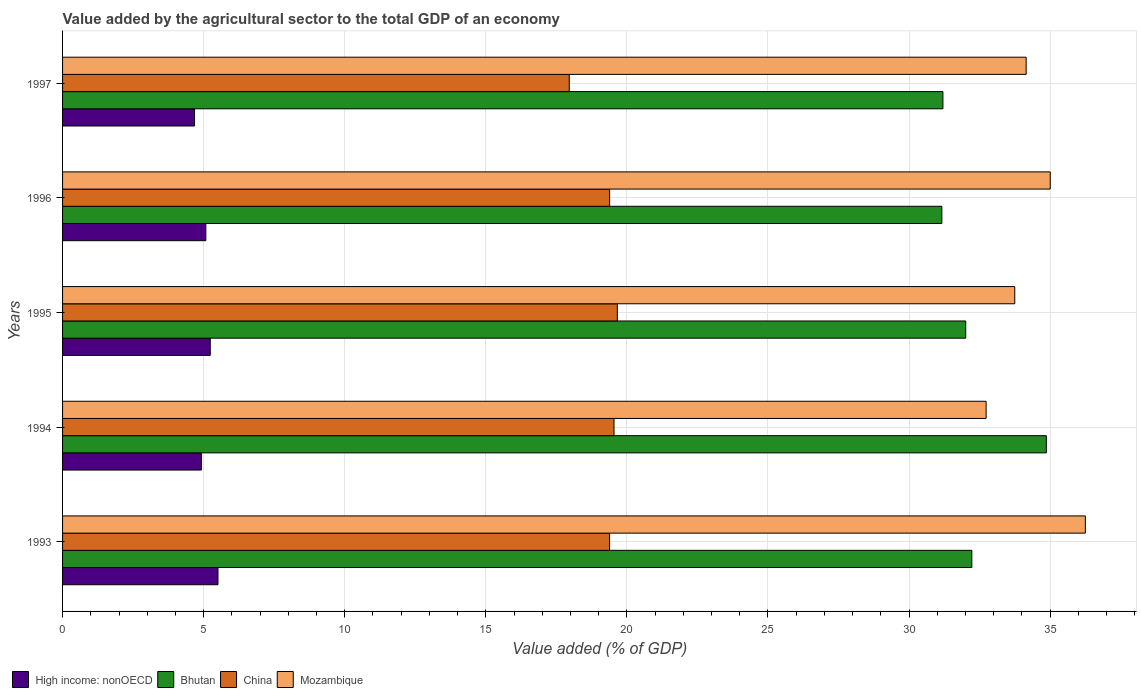How many groups of bars are there?
Provide a short and direct response. 5. Are the number of bars per tick equal to the number of legend labels?
Give a very brief answer. Yes. How many bars are there on the 3rd tick from the bottom?
Ensure brevity in your answer.  4. What is the value added by the agricultural sector to the total GDP in High income: nonOECD in 1996?
Provide a short and direct response. 5.08. Across all years, what is the maximum value added by the agricultural sector to the total GDP in High income: nonOECD?
Your answer should be very brief. 5.51. Across all years, what is the minimum value added by the agricultural sector to the total GDP in China?
Your answer should be very brief. 17.96. In which year was the value added by the agricultural sector to the total GDP in High income: nonOECD maximum?
Your answer should be very brief. 1993. In which year was the value added by the agricultural sector to the total GDP in Mozambique minimum?
Keep it short and to the point. 1994. What is the total value added by the agricultural sector to the total GDP in Mozambique in the graph?
Your answer should be compact. 171.89. What is the difference between the value added by the agricultural sector to the total GDP in China in 1996 and that in 1997?
Your answer should be very brief. 1.43. What is the difference between the value added by the agricultural sector to the total GDP in Mozambique in 1993 and the value added by the agricultural sector to the total GDP in Bhutan in 1996?
Give a very brief answer. 5.09. What is the average value added by the agricultural sector to the total GDP in China per year?
Your answer should be very brief. 19.19. In the year 1993, what is the difference between the value added by the agricultural sector to the total GDP in High income: nonOECD and value added by the agricultural sector to the total GDP in Bhutan?
Provide a short and direct response. -26.72. What is the ratio of the value added by the agricultural sector to the total GDP in High income: nonOECD in 1994 to that in 1997?
Your answer should be compact. 1.05. Is the value added by the agricultural sector to the total GDP in China in 1995 less than that in 1997?
Make the answer very short. No. What is the difference between the highest and the second highest value added by the agricultural sector to the total GDP in Mozambique?
Provide a short and direct response. 1.24. What is the difference between the highest and the lowest value added by the agricultural sector to the total GDP in Bhutan?
Your response must be concise. 3.7. In how many years, is the value added by the agricultural sector to the total GDP in High income: nonOECD greater than the average value added by the agricultural sector to the total GDP in High income: nonOECD taken over all years?
Keep it short and to the point. 2. Is the sum of the value added by the agricultural sector to the total GDP in High income: nonOECD in 1996 and 1997 greater than the maximum value added by the agricultural sector to the total GDP in Mozambique across all years?
Give a very brief answer. No. What does the 3rd bar from the top in 1993 represents?
Your answer should be very brief. Bhutan. What does the 3rd bar from the bottom in 1996 represents?
Keep it short and to the point. China. How many bars are there?
Give a very brief answer. 20. How many years are there in the graph?
Your response must be concise. 5. How many legend labels are there?
Provide a succinct answer. 4. What is the title of the graph?
Keep it short and to the point. Value added by the agricultural sector to the total GDP of an economy. Does "Iceland" appear as one of the legend labels in the graph?
Keep it short and to the point. No. What is the label or title of the X-axis?
Ensure brevity in your answer.  Value added (% of GDP). What is the Value added (% of GDP) in High income: nonOECD in 1993?
Provide a succinct answer. 5.51. What is the Value added (% of GDP) in Bhutan in 1993?
Offer a very short reply. 32.23. What is the Value added (% of GDP) in China in 1993?
Offer a very short reply. 19.39. What is the Value added (% of GDP) in Mozambique in 1993?
Provide a short and direct response. 36.25. What is the Value added (% of GDP) in High income: nonOECD in 1994?
Keep it short and to the point. 4.92. What is the Value added (% of GDP) of Bhutan in 1994?
Your answer should be compact. 34.87. What is the Value added (% of GDP) of China in 1994?
Your response must be concise. 19.54. What is the Value added (% of GDP) in Mozambique in 1994?
Provide a short and direct response. 32.73. What is the Value added (% of GDP) in High income: nonOECD in 1995?
Make the answer very short. 5.23. What is the Value added (% of GDP) in Bhutan in 1995?
Make the answer very short. 32.01. What is the Value added (% of GDP) of China in 1995?
Ensure brevity in your answer.  19.66. What is the Value added (% of GDP) in Mozambique in 1995?
Ensure brevity in your answer.  33.75. What is the Value added (% of GDP) of High income: nonOECD in 1996?
Offer a very short reply. 5.08. What is the Value added (% of GDP) of Bhutan in 1996?
Your response must be concise. 31.16. What is the Value added (% of GDP) in China in 1996?
Your response must be concise. 19.39. What is the Value added (% of GDP) of Mozambique in 1996?
Offer a terse response. 35.01. What is the Value added (% of GDP) in High income: nonOECD in 1997?
Offer a very short reply. 4.68. What is the Value added (% of GDP) in Bhutan in 1997?
Provide a short and direct response. 31.2. What is the Value added (% of GDP) of China in 1997?
Your response must be concise. 17.96. What is the Value added (% of GDP) of Mozambique in 1997?
Your answer should be compact. 34.15. Across all years, what is the maximum Value added (% of GDP) in High income: nonOECD?
Provide a short and direct response. 5.51. Across all years, what is the maximum Value added (% of GDP) of Bhutan?
Keep it short and to the point. 34.87. Across all years, what is the maximum Value added (% of GDP) of China?
Give a very brief answer. 19.66. Across all years, what is the maximum Value added (% of GDP) of Mozambique?
Provide a short and direct response. 36.25. Across all years, what is the minimum Value added (% of GDP) in High income: nonOECD?
Provide a succinct answer. 4.68. Across all years, what is the minimum Value added (% of GDP) in Bhutan?
Keep it short and to the point. 31.16. Across all years, what is the minimum Value added (% of GDP) in China?
Offer a terse response. 17.96. Across all years, what is the minimum Value added (% of GDP) in Mozambique?
Provide a short and direct response. 32.73. What is the total Value added (% of GDP) of High income: nonOECD in the graph?
Ensure brevity in your answer.  25.42. What is the total Value added (% of GDP) of Bhutan in the graph?
Your answer should be very brief. 161.47. What is the total Value added (% of GDP) in China in the graph?
Keep it short and to the point. 95.94. What is the total Value added (% of GDP) of Mozambique in the graph?
Give a very brief answer. 171.89. What is the difference between the Value added (% of GDP) of High income: nonOECD in 1993 and that in 1994?
Ensure brevity in your answer.  0.59. What is the difference between the Value added (% of GDP) of Bhutan in 1993 and that in 1994?
Give a very brief answer. -2.64. What is the difference between the Value added (% of GDP) in China in 1993 and that in 1994?
Give a very brief answer. -0.16. What is the difference between the Value added (% of GDP) in Mozambique in 1993 and that in 1994?
Make the answer very short. 3.52. What is the difference between the Value added (% of GDP) in High income: nonOECD in 1993 and that in 1995?
Your answer should be compact. 0.27. What is the difference between the Value added (% of GDP) in Bhutan in 1993 and that in 1995?
Ensure brevity in your answer.  0.22. What is the difference between the Value added (% of GDP) of China in 1993 and that in 1995?
Offer a terse response. -0.28. What is the difference between the Value added (% of GDP) in Mozambique in 1993 and that in 1995?
Your response must be concise. 2.5. What is the difference between the Value added (% of GDP) of High income: nonOECD in 1993 and that in 1996?
Your answer should be compact. 0.43. What is the difference between the Value added (% of GDP) in Bhutan in 1993 and that in 1996?
Make the answer very short. 1.06. What is the difference between the Value added (% of GDP) of China in 1993 and that in 1996?
Your response must be concise. -0. What is the difference between the Value added (% of GDP) of Mozambique in 1993 and that in 1996?
Give a very brief answer. 1.24. What is the difference between the Value added (% of GDP) in High income: nonOECD in 1993 and that in 1997?
Offer a terse response. 0.83. What is the difference between the Value added (% of GDP) in Bhutan in 1993 and that in 1997?
Ensure brevity in your answer.  1.02. What is the difference between the Value added (% of GDP) of China in 1993 and that in 1997?
Make the answer very short. 1.43. What is the difference between the Value added (% of GDP) of Mozambique in 1993 and that in 1997?
Make the answer very short. 2.1. What is the difference between the Value added (% of GDP) in High income: nonOECD in 1994 and that in 1995?
Offer a very short reply. -0.32. What is the difference between the Value added (% of GDP) of Bhutan in 1994 and that in 1995?
Your answer should be compact. 2.86. What is the difference between the Value added (% of GDP) in China in 1994 and that in 1995?
Make the answer very short. -0.12. What is the difference between the Value added (% of GDP) of Mozambique in 1994 and that in 1995?
Provide a succinct answer. -1.01. What is the difference between the Value added (% of GDP) of High income: nonOECD in 1994 and that in 1996?
Give a very brief answer. -0.16. What is the difference between the Value added (% of GDP) of Bhutan in 1994 and that in 1996?
Provide a short and direct response. 3.7. What is the difference between the Value added (% of GDP) in China in 1994 and that in 1996?
Offer a very short reply. 0.15. What is the difference between the Value added (% of GDP) in Mozambique in 1994 and that in 1996?
Keep it short and to the point. -2.27. What is the difference between the Value added (% of GDP) in High income: nonOECD in 1994 and that in 1997?
Offer a very short reply. 0.24. What is the difference between the Value added (% of GDP) of Bhutan in 1994 and that in 1997?
Make the answer very short. 3.67. What is the difference between the Value added (% of GDP) of China in 1994 and that in 1997?
Provide a short and direct response. 1.59. What is the difference between the Value added (% of GDP) of Mozambique in 1994 and that in 1997?
Make the answer very short. -1.42. What is the difference between the Value added (% of GDP) of High income: nonOECD in 1995 and that in 1996?
Your answer should be compact. 0.16. What is the difference between the Value added (% of GDP) in Bhutan in 1995 and that in 1996?
Offer a terse response. 0.85. What is the difference between the Value added (% of GDP) in China in 1995 and that in 1996?
Offer a very short reply. 0.27. What is the difference between the Value added (% of GDP) in Mozambique in 1995 and that in 1996?
Ensure brevity in your answer.  -1.26. What is the difference between the Value added (% of GDP) in High income: nonOECD in 1995 and that in 1997?
Give a very brief answer. 0.56. What is the difference between the Value added (% of GDP) of Bhutan in 1995 and that in 1997?
Provide a short and direct response. 0.81. What is the difference between the Value added (% of GDP) in China in 1995 and that in 1997?
Offer a very short reply. 1.7. What is the difference between the Value added (% of GDP) of Mozambique in 1995 and that in 1997?
Keep it short and to the point. -0.4. What is the difference between the Value added (% of GDP) in High income: nonOECD in 1996 and that in 1997?
Provide a short and direct response. 0.4. What is the difference between the Value added (% of GDP) of Bhutan in 1996 and that in 1997?
Keep it short and to the point. -0.04. What is the difference between the Value added (% of GDP) in China in 1996 and that in 1997?
Your answer should be very brief. 1.43. What is the difference between the Value added (% of GDP) of Mozambique in 1996 and that in 1997?
Provide a succinct answer. 0.85. What is the difference between the Value added (% of GDP) in High income: nonOECD in 1993 and the Value added (% of GDP) in Bhutan in 1994?
Offer a terse response. -29.36. What is the difference between the Value added (% of GDP) of High income: nonOECD in 1993 and the Value added (% of GDP) of China in 1994?
Your response must be concise. -14.04. What is the difference between the Value added (% of GDP) of High income: nonOECD in 1993 and the Value added (% of GDP) of Mozambique in 1994?
Offer a terse response. -27.23. What is the difference between the Value added (% of GDP) in Bhutan in 1993 and the Value added (% of GDP) in China in 1994?
Your answer should be very brief. 12.68. What is the difference between the Value added (% of GDP) in Bhutan in 1993 and the Value added (% of GDP) in Mozambique in 1994?
Your answer should be very brief. -0.51. What is the difference between the Value added (% of GDP) in China in 1993 and the Value added (% of GDP) in Mozambique in 1994?
Provide a succinct answer. -13.35. What is the difference between the Value added (% of GDP) in High income: nonOECD in 1993 and the Value added (% of GDP) in Bhutan in 1995?
Your answer should be compact. -26.5. What is the difference between the Value added (% of GDP) in High income: nonOECD in 1993 and the Value added (% of GDP) in China in 1995?
Provide a short and direct response. -14.15. What is the difference between the Value added (% of GDP) in High income: nonOECD in 1993 and the Value added (% of GDP) in Mozambique in 1995?
Offer a terse response. -28.24. What is the difference between the Value added (% of GDP) in Bhutan in 1993 and the Value added (% of GDP) in China in 1995?
Provide a succinct answer. 12.56. What is the difference between the Value added (% of GDP) of Bhutan in 1993 and the Value added (% of GDP) of Mozambique in 1995?
Ensure brevity in your answer.  -1.52. What is the difference between the Value added (% of GDP) of China in 1993 and the Value added (% of GDP) of Mozambique in 1995?
Ensure brevity in your answer.  -14.36. What is the difference between the Value added (% of GDP) in High income: nonOECD in 1993 and the Value added (% of GDP) in Bhutan in 1996?
Ensure brevity in your answer.  -25.66. What is the difference between the Value added (% of GDP) of High income: nonOECD in 1993 and the Value added (% of GDP) of China in 1996?
Provide a succinct answer. -13.88. What is the difference between the Value added (% of GDP) in High income: nonOECD in 1993 and the Value added (% of GDP) in Mozambique in 1996?
Your answer should be very brief. -29.5. What is the difference between the Value added (% of GDP) in Bhutan in 1993 and the Value added (% of GDP) in China in 1996?
Give a very brief answer. 12.84. What is the difference between the Value added (% of GDP) of Bhutan in 1993 and the Value added (% of GDP) of Mozambique in 1996?
Provide a succinct answer. -2.78. What is the difference between the Value added (% of GDP) in China in 1993 and the Value added (% of GDP) in Mozambique in 1996?
Your answer should be compact. -15.62. What is the difference between the Value added (% of GDP) of High income: nonOECD in 1993 and the Value added (% of GDP) of Bhutan in 1997?
Your response must be concise. -25.69. What is the difference between the Value added (% of GDP) in High income: nonOECD in 1993 and the Value added (% of GDP) in China in 1997?
Offer a terse response. -12.45. What is the difference between the Value added (% of GDP) of High income: nonOECD in 1993 and the Value added (% of GDP) of Mozambique in 1997?
Give a very brief answer. -28.64. What is the difference between the Value added (% of GDP) of Bhutan in 1993 and the Value added (% of GDP) of China in 1997?
Your answer should be very brief. 14.27. What is the difference between the Value added (% of GDP) in Bhutan in 1993 and the Value added (% of GDP) in Mozambique in 1997?
Provide a succinct answer. -1.93. What is the difference between the Value added (% of GDP) of China in 1993 and the Value added (% of GDP) of Mozambique in 1997?
Provide a short and direct response. -14.76. What is the difference between the Value added (% of GDP) of High income: nonOECD in 1994 and the Value added (% of GDP) of Bhutan in 1995?
Keep it short and to the point. -27.09. What is the difference between the Value added (% of GDP) of High income: nonOECD in 1994 and the Value added (% of GDP) of China in 1995?
Provide a succinct answer. -14.74. What is the difference between the Value added (% of GDP) of High income: nonOECD in 1994 and the Value added (% of GDP) of Mozambique in 1995?
Provide a succinct answer. -28.83. What is the difference between the Value added (% of GDP) in Bhutan in 1994 and the Value added (% of GDP) in China in 1995?
Give a very brief answer. 15.21. What is the difference between the Value added (% of GDP) in Bhutan in 1994 and the Value added (% of GDP) in Mozambique in 1995?
Make the answer very short. 1.12. What is the difference between the Value added (% of GDP) in China in 1994 and the Value added (% of GDP) in Mozambique in 1995?
Your answer should be compact. -14.2. What is the difference between the Value added (% of GDP) of High income: nonOECD in 1994 and the Value added (% of GDP) of Bhutan in 1996?
Offer a very short reply. -26.24. What is the difference between the Value added (% of GDP) in High income: nonOECD in 1994 and the Value added (% of GDP) in China in 1996?
Provide a succinct answer. -14.47. What is the difference between the Value added (% of GDP) of High income: nonOECD in 1994 and the Value added (% of GDP) of Mozambique in 1996?
Offer a very short reply. -30.09. What is the difference between the Value added (% of GDP) in Bhutan in 1994 and the Value added (% of GDP) in China in 1996?
Provide a succinct answer. 15.48. What is the difference between the Value added (% of GDP) of Bhutan in 1994 and the Value added (% of GDP) of Mozambique in 1996?
Provide a succinct answer. -0.14. What is the difference between the Value added (% of GDP) in China in 1994 and the Value added (% of GDP) in Mozambique in 1996?
Provide a short and direct response. -15.46. What is the difference between the Value added (% of GDP) of High income: nonOECD in 1994 and the Value added (% of GDP) of Bhutan in 1997?
Make the answer very short. -26.28. What is the difference between the Value added (% of GDP) of High income: nonOECD in 1994 and the Value added (% of GDP) of China in 1997?
Your answer should be compact. -13.04. What is the difference between the Value added (% of GDP) of High income: nonOECD in 1994 and the Value added (% of GDP) of Mozambique in 1997?
Offer a terse response. -29.23. What is the difference between the Value added (% of GDP) in Bhutan in 1994 and the Value added (% of GDP) in China in 1997?
Make the answer very short. 16.91. What is the difference between the Value added (% of GDP) in Bhutan in 1994 and the Value added (% of GDP) in Mozambique in 1997?
Give a very brief answer. 0.72. What is the difference between the Value added (% of GDP) of China in 1994 and the Value added (% of GDP) of Mozambique in 1997?
Your answer should be very brief. -14.61. What is the difference between the Value added (% of GDP) of High income: nonOECD in 1995 and the Value added (% of GDP) of Bhutan in 1996?
Give a very brief answer. -25.93. What is the difference between the Value added (% of GDP) in High income: nonOECD in 1995 and the Value added (% of GDP) in China in 1996?
Offer a terse response. -14.16. What is the difference between the Value added (% of GDP) of High income: nonOECD in 1995 and the Value added (% of GDP) of Mozambique in 1996?
Offer a very short reply. -29.77. What is the difference between the Value added (% of GDP) in Bhutan in 1995 and the Value added (% of GDP) in China in 1996?
Give a very brief answer. 12.62. What is the difference between the Value added (% of GDP) of Bhutan in 1995 and the Value added (% of GDP) of Mozambique in 1996?
Offer a terse response. -3. What is the difference between the Value added (% of GDP) in China in 1995 and the Value added (% of GDP) in Mozambique in 1996?
Offer a terse response. -15.34. What is the difference between the Value added (% of GDP) in High income: nonOECD in 1995 and the Value added (% of GDP) in Bhutan in 1997?
Offer a terse response. -25.97. What is the difference between the Value added (% of GDP) of High income: nonOECD in 1995 and the Value added (% of GDP) of China in 1997?
Offer a terse response. -12.72. What is the difference between the Value added (% of GDP) of High income: nonOECD in 1995 and the Value added (% of GDP) of Mozambique in 1997?
Provide a succinct answer. -28.92. What is the difference between the Value added (% of GDP) in Bhutan in 1995 and the Value added (% of GDP) in China in 1997?
Keep it short and to the point. 14.05. What is the difference between the Value added (% of GDP) of Bhutan in 1995 and the Value added (% of GDP) of Mozambique in 1997?
Ensure brevity in your answer.  -2.14. What is the difference between the Value added (% of GDP) of China in 1995 and the Value added (% of GDP) of Mozambique in 1997?
Give a very brief answer. -14.49. What is the difference between the Value added (% of GDP) in High income: nonOECD in 1996 and the Value added (% of GDP) in Bhutan in 1997?
Provide a succinct answer. -26.12. What is the difference between the Value added (% of GDP) in High income: nonOECD in 1996 and the Value added (% of GDP) in China in 1997?
Ensure brevity in your answer.  -12.88. What is the difference between the Value added (% of GDP) in High income: nonOECD in 1996 and the Value added (% of GDP) in Mozambique in 1997?
Provide a short and direct response. -29.07. What is the difference between the Value added (% of GDP) of Bhutan in 1996 and the Value added (% of GDP) of China in 1997?
Keep it short and to the point. 13.21. What is the difference between the Value added (% of GDP) of Bhutan in 1996 and the Value added (% of GDP) of Mozambique in 1997?
Make the answer very short. -2.99. What is the difference between the Value added (% of GDP) of China in 1996 and the Value added (% of GDP) of Mozambique in 1997?
Provide a succinct answer. -14.76. What is the average Value added (% of GDP) in High income: nonOECD per year?
Offer a terse response. 5.08. What is the average Value added (% of GDP) of Bhutan per year?
Keep it short and to the point. 32.29. What is the average Value added (% of GDP) of China per year?
Your answer should be very brief. 19.19. What is the average Value added (% of GDP) of Mozambique per year?
Your response must be concise. 34.38. In the year 1993, what is the difference between the Value added (% of GDP) in High income: nonOECD and Value added (% of GDP) in Bhutan?
Your response must be concise. -26.72. In the year 1993, what is the difference between the Value added (% of GDP) of High income: nonOECD and Value added (% of GDP) of China?
Your answer should be very brief. -13.88. In the year 1993, what is the difference between the Value added (% of GDP) in High income: nonOECD and Value added (% of GDP) in Mozambique?
Offer a very short reply. -30.74. In the year 1993, what is the difference between the Value added (% of GDP) in Bhutan and Value added (% of GDP) in China?
Provide a short and direct response. 12.84. In the year 1993, what is the difference between the Value added (% of GDP) of Bhutan and Value added (% of GDP) of Mozambique?
Offer a terse response. -4.02. In the year 1993, what is the difference between the Value added (% of GDP) of China and Value added (% of GDP) of Mozambique?
Offer a very short reply. -16.86. In the year 1994, what is the difference between the Value added (% of GDP) in High income: nonOECD and Value added (% of GDP) in Bhutan?
Make the answer very short. -29.95. In the year 1994, what is the difference between the Value added (% of GDP) of High income: nonOECD and Value added (% of GDP) of China?
Offer a very short reply. -14.63. In the year 1994, what is the difference between the Value added (% of GDP) of High income: nonOECD and Value added (% of GDP) of Mozambique?
Give a very brief answer. -27.81. In the year 1994, what is the difference between the Value added (% of GDP) in Bhutan and Value added (% of GDP) in China?
Provide a succinct answer. 15.32. In the year 1994, what is the difference between the Value added (% of GDP) of Bhutan and Value added (% of GDP) of Mozambique?
Your answer should be compact. 2.13. In the year 1994, what is the difference between the Value added (% of GDP) of China and Value added (% of GDP) of Mozambique?
Keep it short and to the point. -13.19. In the year 1995, what is the difference between the Value added (% of GDP) of High income: nonOECD and Value added (% of GDP) of Bhutan?
Give a very brief answer. -26.78. In the year 1995, what is the difference between the Value added (% of GDP) of High income: nonOECD and Value added (% of GDP) of China?
Keep it short and to the point. -14.43. In the year 1995, what is the difference between the Value added (% of GDP) in High income: nonOECD and Value added (% of GDP) in Mozambique?
Your answer should be very brief. -28.51. In the year 1995, what is the difference between the Value added (% of GDP) in Bhutan and Value added (% of GDP) in China?
Keep it short and to the point. 12.35. In the year 1995, what is the difference between the Value added (% of GDP) in Bhutan and Value added (% of GDP) in Mozambique?
Give a very brief answer. -1.74. In the year 1995, what is the difference between the Value added (% of GDP) in China and Value added (% of GDP) in Mozambique?
Offer a terse response. -14.09. In the year 1996, what is the difference between the Value added (% of GDP) of High income: nonOECD and Value added (% of GDP) of Bhutan?
Offer a very short reply. -26.09. In the year 1996, what is the difference between the Value added (% of GDP) of High income: nonOECD and Value added (% of GDP) of China?
Provide a succinct answer. -14.31. In the year 1996, what is the difference between the Value added (% of GDP) of High income: nonOECD and Value added (% of GDP) of Mozambique?
Your answer should be compact. -29.93. In the year 1996, what is the difference between the Value added (% of GDP) of Bhutan and Value added (% of GDP) of China?
Make the answer very short. 11.77. In the year 1996, what is the difference between the Value added (% of GDP) in Bhutan and Value added (% of GDP) in Mozambique?
Your answer should be compact. -3.84. In the year 1996, what is the difference between the Value added (% of GDP) of China and Value added (% of GDP) of Mozambique?
Make the answer very short. -15.62. In the year 1997, what is the difference between the Value added (% of GDP) of High income: nonOECD and Value added (% of GDP) of Bhutan?
Provide a succinct answer. -26.53. In the year 1997, what is the difference between the Value added (% of GDP) in High income: nonOECD and Value added (% of GDP) in China?
Keep it short and to the point. -13.28. In the year 1997, what is the difference between the Value added (% of GDP) of High income: nonOECD and Value added (% of GDP) of Mozambique?
Your answer should be compact. -29.48. In the year 1997, what is the difference between the Value added (% of GDP) of Bhutan and Value added (% of GDP) of China?
Your answer should be compact. 13.24. In the year 1997, what is the difference between the Value added (% of GDP) of Bhutan and Value added (% of GDP) of Mozambique?
Keep it short and to the point. -2.95. In the year 1997, what is the difference between the Value added (% of GDP) in China and Value added (% of GDP) in Mozambique?
Your answer should be compact. -16.19. What is the ratio of the Value added (% of GDP) of High income: nonOECD in 1993 to that in 1994?
Offer a terse response. 1.12. What is the ratio of the Value added (% of GDP) of Bhutan in 1993 to that in 1994?
Keep it short and to the point. 0.92. What is the ratio of the Value added (% of GDP) in China in 1993 to that in 1994?
Offer a very short reply. 0.99. What is the ratio of the Value added (% of GDP) in Mozambique in 1993 to that in 1994?
Keep it short and to the point. 1.11. What is the ratio of the Value added (% of GDP) of High income: nonOECD in 1993 to that in 1995?
Make the answer very short. 1.05. What is the ratio of the Value added (% of GDP) in Bhutan in 1993 to that in 1995?
Provide a short and direct response. 1.01. What is the ratio of the Value added (% of GDP) in China in 1993 to that in 1995?
Offer a very short reply. 0.99. What is the ratio of the Value added (% of GDP) of Mozambique in 1993 to that in 1995?
Make the answer very short. 1.07. What is the ratio of the Value added (% of GDP) of High income: nonOECD in 1993 to that in 1996?
Your response must be concise. 1.08. What is the ratio of the Value added (% of GDP) of Bhutan in 1993 to that in 1996?
Make the answer very short. 1.03. What is the ratio of the Value added (% of GDP) in China in 1993 to that in 1996?
Offer a very short reply. 1. What is the ratio of the Value added (% of GDP) of Mozambique in 1993 to that in 1996?
Your answer should be compact. 1.04. What is the ratio of the Value added (% of GDP) of High income: nonOECD in 1993 to that in 1997?
Offer a terse response. 1.18. What is the ratio of the Value added (% of GDP) of Bhutan in 1993 to that in 1997?
Your response must be concise. 1.03. What is the ratio of the Value added (% of GDP) in China in 1993 to that in 1997?
Provide a succinct answer. 1.08. What is the ratio of the Value added (% of GDP) of Mozambique in 1993 to that in 1997?
Offer a very short reply. 1.06. What is the ratio of the Value added (% of GDP) in High income: nonOECD in 1994 to that in 1995?
Keep it short and to the point. 0.94. What is the ratio of the Value added (% of GDP) in Bhutan in 1994 to that in 1995?
Your answer should be compact. 1.09. What is the ratio of the Value added (% of GDP) of Mozambique in 1994 to that in 1995?
Your response must be concise. 0.97. What is the ratio of the Value added (% of GDP) in High income: nonOECD in 1994 to that in 1996?
Ensure brevity in your answer.  0.97. What is the ratio of the Value added (% of GDP) in Bhutan in 1994 to that in 1996?
Give a very brief answer. 1.12. What is the ratio of the Value added (% of GDP) of China in 1994 to that in 1996?
Provide a succinct answer. 1.01. What is the ratio of the Value added (% of GDP) in Mozambique in 1994 to that in 1996?
Your answer should be very brief. 0.94. What is the ratio of the Value added (% of GDP) in High income: nonOECD in 1994 to that in 1997?
Your response must be concise. 1.05. What is the ratio of the Value added (% of GDP) of Bhutan in 1994 to that in 1997?
Offer a terse response. 1.12. What is the ratio of the Value added (% of GDP) in China in 1994 to that in 1997?
Offer a very short reply. 1.09. What is the ratio of the Value added (% of GDP) in Mozambique in 1994 to that in 1997?
Make the answer very short. 0.96. What is the ratio of the Value added (% of GDP) of High income: nonOECD in 1995 to that in 1996?
Your response must be concise. 1.03. What is the ratio of the Value added (% of GDP) in Bhutan in 1995 to that in 1996?
Offer a terse response. 1.03. What is the ratio of the Value added (% of GDP) of China in 1995 to that in 1996?
Offer a terse response. 1.01. What is the ratio of the Value added (% of GDP) of Mozambique in 1995 to that in 1996?
Offer a terse response. 0.96. What is the ratio of the Value added (% of GDP) in High income: nonOECD in 1995 to that in 1997?
Offer a terse response. 1.12. What is the ratio of the Value added (% of GDP) of Bhutan in 1995 to that in 1997?
Provide a short and direct response. 1.03. What is the ratio of the Value added (% of GDP) in China in 1995 to that in 1997?
Provide a succinct answer. 1.09. What is the ratio of the Value added (% of GDP) in Mozambique in 1995 to that in 1997?
Give a very brief answer. 0.99. What is the ratio of the Value added (% of GDP) of High income: nonOECD in 1996 to that in 1997?
Keep it short and to the point. 1.09. What is the ratio of the Value added (% of GDP) of China in 1996 to that in 1997?
Provide a short and direct response. 1.08. What is the ratio of the Value added (% of GDP) of Mozambique in 1996 to that in 1997?
Your answer should be compact. 1.02. What is the difference between the highest and the second highest Value added (% of GDP) in High income: nonOECD?
Offer a terse response. 0.27. What is the difference between the highest and the second highest Value added (% of GDP) in Bhutan?
Keep it short and to the point. 2.64. What is the difference between the highest and the second highest Value added (% of GDP) of China?
Offer a very short reply. 0.12. What is the difference between the highest and the second highest Value added (% of GDP) of Mozambique?
Provide a succinct answer. 1.24. What is the difference between the highest and the lowest Value added (% of GDP) of High income: nonOECD?
Ensure brevity in your answer.  0.83. What is the difference between the highest and the lowest Value added (% of GDP) of Bhutan?
Keep it short and to the point. 3.7. What is the difference between the highest and the lowest Value added (% of GDP) of China?
Ensure brevity in your answer.  1.7. What is the difference between the highest and the lowest Value added (% of GDP) in Mozambique?
Offer a very short reply. 3.52. 